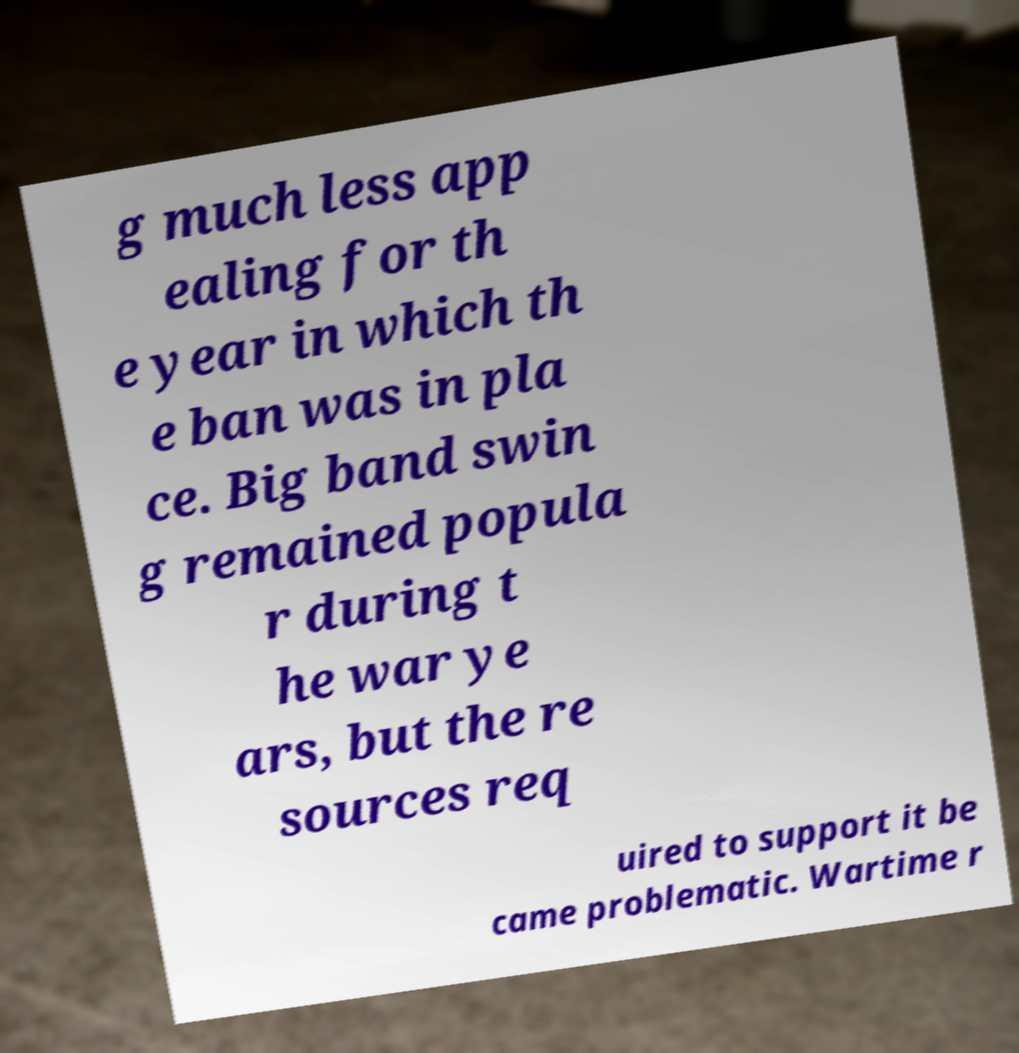Can you accurately transcribe the text from the provided image for me? g much less app ealing for th e year in which th e ban was in pla ce. Big band swin g remained popula r during t he war ye ars, but the re sources req uired to support it be came problematic. Wartime r 